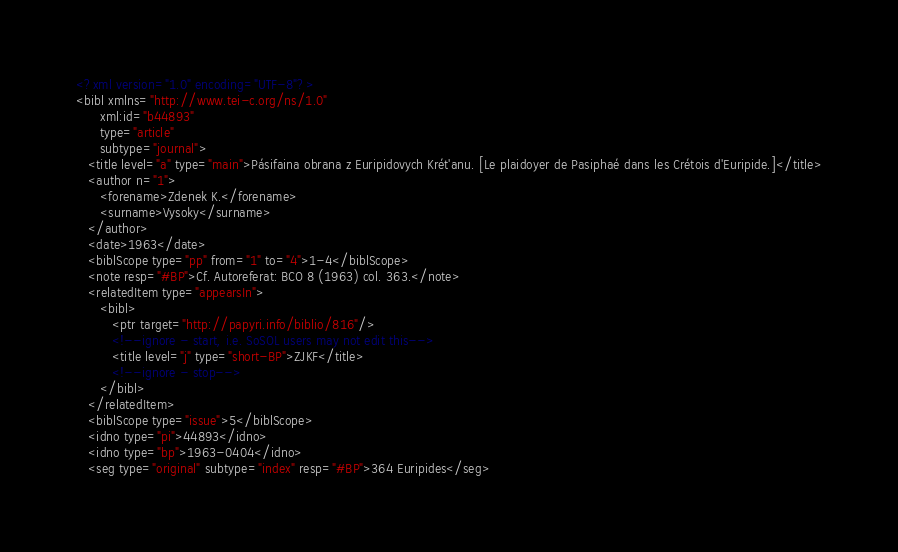<code> <loc_0><loc_0><loc_500><loc_500><_XML_><?xml version="1.0" encoding="UTF-8"?>
<bibl xmlns="http://www.tei-c.org/ns/1.0"
      xml:id="b44893"
      type="article"
      subtype="journal">
   <title level="a" type="main">Pásifaina obrana z Euripidovych Krét'anu. [Le plaidoyer de Pasiphaé dans les Crétois d'Euripide.]</title>
   <author n="1">
      <forename>Zdenek K.</forename>
      <surname>Vysoky</surname>
   </author>
   <date>1963</date>
   <biblScope type="pp" from="1" to="4">1-4</biblScope>
   <note resp="#BP">Cf. Autoreferat: BCO 8 (1963) col. 363.</note>
   <relatedItem type="appearsIn">
      <bibl>
         <ptr target="http://papyri.info/biblio/816"/>
         <!--ignore - start, i.e. SoSOL users may not edit this-->
         <title level="j" type="short-BP">ZJKF</title>
         <!--ignore - stop-->
      </bibl>
   </relatedItem>
   <biblScope type="issue">5</biblScope>
   <idno type="pi">44893</idno>
   <idno type="bp">1963-0404</idno>
   <seg type="original" subtype="index" resp="#BP">364 Euripides</seg></code> 